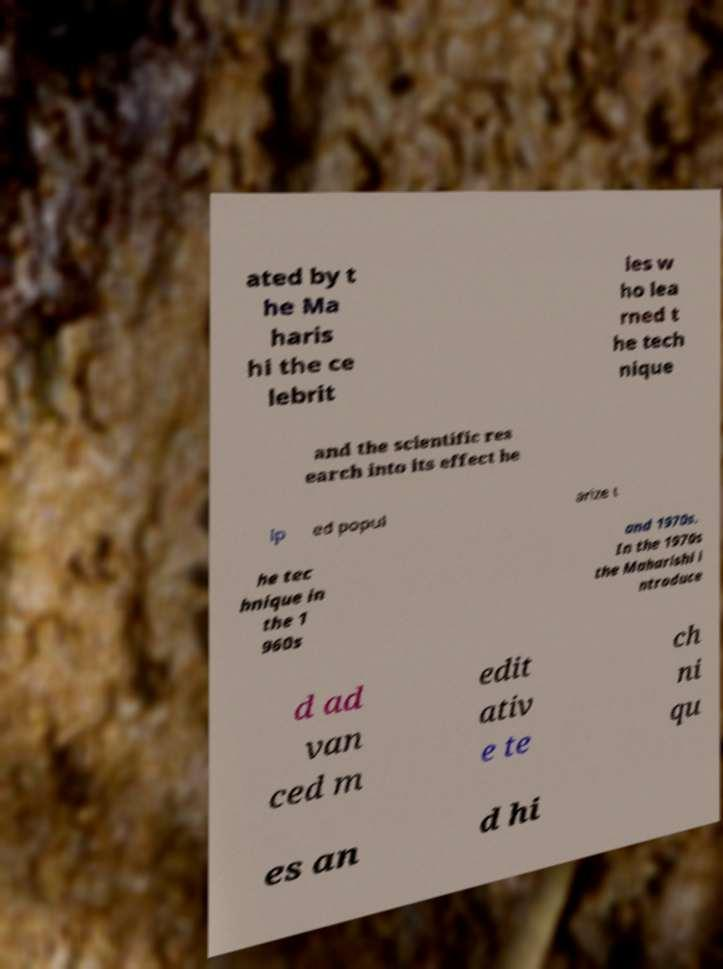Please read and relay the text visible in this image. What does it say? ated by t he Ma haris hi the ce lebrit ies w ho lea rned t he tech nique and the scientific res earch into its effect he lp ed popul arize t he tec hnique in the 1 960s and 1970s. In the 1970s the Maharishi i ntroduce d ad van ced m edit ativ e te ch ni qu es an d hi 